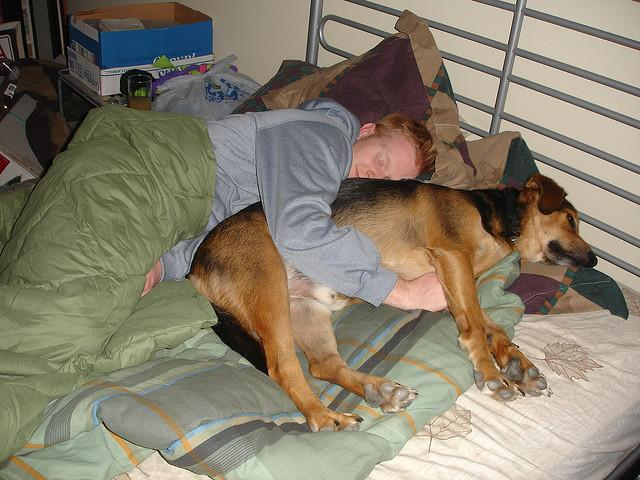What is the owner giving his dog?

Choices:
A) time out
B) food
C) hug
D) medication hug 